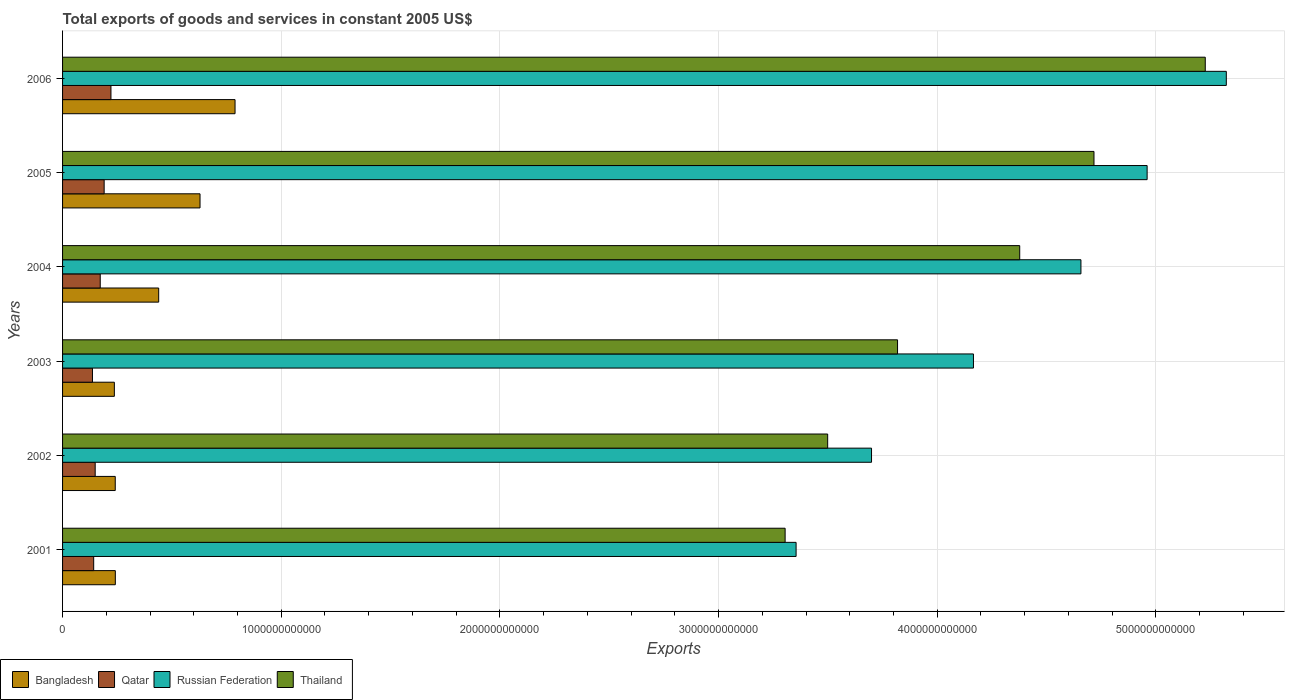Are the number of bars per tick equal to the number of legend labels?
Your answer should be very brief. Yes. How many bars are there on the 2nd tick from the bottom?
Offer a terse response. 4. In how many cases, is the number of bars for a given year not equal to the number of legend labels?
Your answer should be compact. 0. What is the total exports of goods and services in Thailand in 2004?
Your answer should be very brief. 4.38e+12. Across all years, what is the maximum total exports of goods and services in Russian Federation?
Provide a short and direct response. 5.32e+12. Across all years, what is the minimum total exports of goods and services in Bangladesh?
Keep it short and to the point. 2.37e+11. In which year was the total exports of goods and services in Russian Federation maximum?
Provide a short and direct response. 2006. In which year was the total exports of goods and services in Qatar minimum?
Your response must be concise. 2003. What is the total total exports of goods and services in Qatar in the graph?
Provide a short and direct response. 1.01e+12. What is the difference between the total exports of goods and services in Russian Federation in 2003 and that in 2004?
Provide a succinct answer. -4.92e+11. What is the difference between the total exports of goods and services in Bangladesh in 2004 and the total exports of goods and services in Thailand in 2005?
Give a very brief answer. -4.28e+12. What is the average total exports of goods and services in Russian Federation per year?
Offer a very short reply. 4.36e+12. In the year 2006, what is the difference between the total exports of goods and services in Qatar and total exports of goods and services in Russian Federation?
Provide a succinct answer. -5.10e+12. What is the ratio of the total exports of goods and services in Thailand in 2002 to that in 2006?
Your answer should be very brief. 0.67. Is the difference between the total exports of goods and services in Qatar in 2003 and 2005 greater than the difference between the total exports of goods and services in Russian Federation in 2003 and 2005?
Provide a succinct answer. Yes. What is the difference between the highest and the second highest total exports of goods and services in Bangladesh?
Offer a terse response. 1.60e+11. What is the difference between the highest and the lowest total exports of goods and services in Bangladesh?
Offer a very short reply. 5.52e+11. In how many years, is the total exports of goods and services in Russian Federation greater than the average total exports of goods and services in Russian Federation taken over all years?
Keep it short and to the point. 3. Is the sum of the total exports of goods and services in Qatar in 2001 and 2005 greater than the maximum total exports of goods and services in Bangladesh across all years?
Your response must be concise. No. What does the 4th bar from the top in 2005 represents?
Offer a very short reply. Bangladesh. What does the 2nd bar from the bottom in 2006 represents?
Your answer should be very brief. Qatar. Is it the case that in every year, the sum of the total exports of goods and services in Russian Federation and total exports of goods and services in Thailand is greater than the total exports of goods and services in Qatar?
Provide a short and direct response. Yes. How many bars are there?
Offer a terse response. 24. How many years are there in the graph?
Provide a short and direct response. 6. What is the difference between two consecutive major ticks on the X-axis?
Your response must be concise. 1.00e+12. Does the graph contain grids?
Give a very brief answer. Yes. Where does the legend appear in the graph?
Make the answer very short. Bottom left. How are the legend labels stacked?
Provide a short and direct response. Horizontal. What is the title of the graph?
Provide a short and direct response. Total exports of goods and services in constant 2005 US$. Does "Nepal" appear as one of the legend labels in the graph?
Your answer should be compact. No. What is the label or title of the X-axis?
Offer a terse response. Exports. What is the Exports in Bangladesh in 2001?
Make the answer very short. 2.41e+11. What is the Exports of Qatar in 2001?
Offer a terse response. 1.42e+11. What is the Exports of Russian Federation in 2001?
Your answer should be very brief. 3.35e+12. What is the Exports of Thailand in 2001?
Your response must be concise. 3.30e+12. What is the Exports of Bangladesh in 2002?
Your answer should be compact. 2.41e+11. What is the Exports in Qatar in 2002?
Your response must be concise. 1.49e+11. What is the Exports in Russian Federation in 2002?
Ensure brevity in your answer.  3.70e+12. What is the Exports of Thailand in 2002?
Offer a terse response. 3.50e+12. What is the Exports of Bangladesh in 2003?
Give a very brief answer. 2.37e+11. What is the Exports in Qatar in 2003?
Ensure brevity in your answer.  1.37e+11. What is the Exports of Russian Federation in 2003?
Provide a short and direct response. 4.17e+12. What is the Exports in Thailand in 2003?
Give a very brief answer. 3.82e+12. What is the Exports in Bangladesh in 2004?
Provide a short and direct response. 4.40e+11. What is the Exports of Qatar in 2004?
Your answer should be compact. 1.72e+11. What is the Exports in Russian Federation in 2004?
Ensure brevity in your answer.  4.66e+12. What is the Exports of Thailand in 2004?
Offer a very short reply. 4.38e+12. What is the Exports in Bangladesh in 2005?
Give a very brief answer. 6.29e+11. What is the Exports in Qatar in 2005?
Offer a very short reply. 1.90e+11. What is the Exports in Russian Federation in 2005?
Your answer should be very brief. 4.96e+12. What is the Exports of Thailand in 2005?
Give a very brief answer. 4.72e+12. What is the Exports of Bangladesh in 2006?
Make the answer very short. 7.89e+11. What is the Exports of Qatar in 2006?
Make the answer very short. 2.21e+11. What is the Exports in Russian Federation in 2006?
Offer a terse response. 5.32e+12. What is the Exports of Thailand in 2006?
Provide a succinct answer. 5.23e+12. Across all years, what is the maximum Exports of Bangladesh?
Ensure brevity in your answer.  7.89e+11. Across all years, what is the maximum Exports of Qatar?
Make the answer very short. 2.21e+11. Across all years, what is the maximum Exports in Russian Federation?
Ensure brevity in your answer.  5.32e+12. Across all years, what is the maximum Exports of Thailand?
Provide a short and direct response. 5.23e+12. Across all years, what is the minimum Exports in Bangladesh?
Your answer should be very brief. 2.37e+11. Across all years, what is the minimum Exports in Qatar?
Offer a terse response. 1.37e+11. Across all years, what is the minimum Exports of Russian Federation?
Your answer should be compact. 3.35e+12. Across all years, what is the minimum Exports of Thailand?
Your answer should be compact. 3.30e+12. What is the total Exports of Bangladesh in the graph?
Make the answer very short. 2.58e+12. What is the total Exports in Qatar in the graph?
Provide a succinct answer. 1.01e+12. What is the total Exports in Russian Federation in the graph?
Your answer should be very brief. 2.62e+13. What is the total Exports in Thailand in the graph?
Your answer should be compact. 2.49e+13. What is the difference between the Exports in Bangladesh in 2001 and that in 2002?
Your response must be concise. 3.96e+08. What is the difference between the Exports of Qatar in 2001 and that in 2002?
Ensure brevity in your answer.  -6.82e+09. What is the difference between the Exports of Russian Federation in 2001 and that in 2002?
Offer a very short reply. -3.45e+11. What is the difference between the Exports of Thailand in 2001 and that in 2002?
Your response must be concise. -1.95e+11. What is the difference between the Exports in Bangladesh in 2001 and that in 2003?
Make the answer very short. 4.48e+09. What is the difference between the Exports of Qatar in 2001 and that in 2003?
Ensure brevity in your answer.  5.58e+09. What is the difference between the Exports of Russian Federation in 2001 and that in 2003?
Offer a terse response. -8.11e+11. What is the difference between the Exports in Thailand in 2001 and that in 2003?
Offer a terse response. -5.14e+11. What is the difference between the Exports in Bangladesh in 2001 and that in 2004?
Provide a short and direct response. -1.98e+11. What is the difference between the Exports of Qatar in 2001 and that in 2004?
Keep it short and to the point. -3.00e+1. What is the difference between the Exports of Russian Federation in 2001 and that in 2004?
Provide a short and direct response. -1.30e+12. What is the difference between the Exports in Thailand in 2001 and that in 2004?
Offer a very short reply. -1.07e+12. What is the difference between the Exports in Bangladesh in 2001 and that in 2005?
Keep it short and to the point. -3.87e+11. What is the difference between the Exports in Qatar in 2001 and that in 2005?
Offer a very short reply. -4.78e+1. What is the difference between the Exports of Russian Federation in 2001 and that in 2005?
Your response must be concise. -1.61e+12. What is the difference between the Exports in Thailand in 2001 and that in 2005?
Offer a terse response. -1.41e+12. What is the difference between the Exports in Bangladesh in 2001 and that in 2006?
Your response must be concise. -5.47e+11. What is the difference between the Exports in Qatar in 2001 and that in 2006?
Your answer should be compact. -7.90e+1. What is the difference between the Exports of Russian Federation in 2001 and that in 2006?
Make the answer very short. -1.97e+12. What is the difference between the Exports in Thailand in 2001 and that in 2006?
Keep it short and to the point. -1.92e+12. What is the difference between the Exports of Bangladesh in 2002 and that in 2003?
Give a very brief answer. 4.09e+09. What is the difference between the Exports of Qatar in 2002 and that in 2003?
Provide a succinct answer. 1.24e+1. What is the difference between the Exports of Russian Federation in 2002 and that in 2003?
Your answer should be compact. -4.66e+11. What is the difference between the Exports of Thailand in 2002 and that in 2003?
Provide a short and direct response. -3.20e+11. What is the difference between the Exports of Bangladesh in 2002 and that in 2004?
Offer a very short reply. -1.99e+11. What is the difference between the Exports of Qatar in 2002 and that in 2004?
Give a very brief answer. -2.31e+1. What is the difference between the Exports of Russian Federation in 2002 and that in 2004?
Your answer should be compact. -9.58e+11. What is the difference between the Exports in Thailand in 2002 and that in 2004?
Provide a short and direct response. -8.78e+11. What is the difference between the Exports of Bangladesh in 2002 and that in 2005?
Provide a short and direct response. -3.88e+11. What is the difference between the Exports of Qatar in 2002 and that in 2005?
Your answer should be compact. -4.10e+1. What is the difference between the Exports of Russian Federation in 2002 and that in 2005?
Provide a succinct answer. -1.26e+12. What is the difference between the Exports of Thailand in 2002 and that in 2005?
Your answer should be compact. -1.22e+12. What is the difference between the Exports of Bangladesh in 2002 and that in 2006?
Keep it short and to the point. -5.48e+11. What is the difference between the Exports in Qatar in 2002 and that in 2006?
Your response must be concise. -7.21e+1. What is the difference between the Exports in Russian Federation in 2002 and that in 2006?
Your answer should be very brief. -1.62e+12. What is the difference between the Exports of Thailand in 2002 and that in 2006?
Your answer should be compact. -1.73e+12. What is the difference between the Exports in Bangladesh in 2003 and that in 2004?
Your response must be concise. -2.03e+11. What is the difference between the Exports in Qatar in 2003 and that in 2004?
Offer a terse response. -3.55e+1. What is the difference between the Exports in Russian Federation in 2003 and that in 2004?
Your answer should be compact. -4.92e+11. What is the difference between the Exports of Thailand in 2003 and that in 2004?
Provide a short and direct response. -5.59e+11. What is the difference between the Exports of Bangladesh in 2003 and that in 2005?
Your answer should be compact. -3.92e+11. What is the difference between the Exports in Qatar in 2003 and that in 2005?
Make the answer very short. -5.34e+1. What is the difference between the Exports in Russian Federation in 2003 and that in 2005?
Your answer should be very brief. -7.94e+11. What is the difference between the Exports of Thailand in 2003 and that in 2005?
Offer a very short reply. -8.98e+11. What is the difference between the Exports of Bangladesh in 2003 and that in 2006?
Your answer should be very brief. -5.52e+11. What is the difference between the Exports in Qatar in 2003 and that in 2006?
Provide a succinct answer. -8.45e+1. What is the difference between the Exports in Russian Federation in 2003 and that in 2006?
Keep it short and to the point. -1.16e+12. What is the difference between the Exports of Thailand in 2003 and that in 2006?
Make the answer very short. -1.41e+12. What is the difference between the Exports of Bangladesh in 2004 and that in 2005?
Make the answer very short. -1.89e+11. What is the difference between the Exports of Qatar in 2004 and that in 2005?
Give a very brief answer. -1.79e+1. What is the difference between the Exports in Russian Federation in 2004 and that in 2005?
Give a very brief answer. -3.03e+11. What is the difference between the Exports in Thailand in 2004 and that in 2005?
Offer a very short reply. -3.40e+11. What is the difference between the Exports of Bangladesh in 2004 and that in 2006?
Your answer should be compact. -3.49e+11. What is the difference between the Exports in Qatar in 2004 and that in 2006?
Offer a very short reply. -4.90e+1. What is the difference between the Exports in Russian Federation in 2004 and that in 2006?
Provide a short and direct response. -6.65e+11. What is the difference between the Exports of Thailand in 2004 and that in 2006?
Make the answer very short. -8.49e+11. What is the difference between the Exports of Bangladesh in 2005 and that in 2006?
Make the answer very short. -1.60e+11. What is the difference between the Exports of Qatar in 2005 and that in 2006?
Your answer should be very brief. -3.11e+1. What is the difference between the Exports of Russian Federation in 2005 and that in 2006?
Offer a terse response. -3.62e+11. What is the difference between the Exports in Thailand in 2005 and that in 2006?
Ensure brevity in your answer.  -5.09e+11. What is the difference between the Exports in Bangladesh in 2001 and the Exports in Qatar in 2002?
Your answer should be very brief. 9.22e+1. What is the difference between the Exports of Bangladesh in 2001 and the Exports of Russian Federation in 2002?
Your answer should be compact. -3.46e+12. What is the difference between the Exports of Bangladesh in 2001 and the Exports of Thailand in 2002?
Provide a short and direct response. -3.26e+12. What is the difference between the Exports of Qatar in 2001 and the Exports of Russian Federation in 2002?
Provide a short and direct response. -3.56e+12. What is the difference between the Exports in Qatar in 2001 and the Exports in Thailand in 2002?
Make the answer very short. -3.36e+12. What is the difference between the Exports of Russian Federation in 2001 and the Exports of Thailand in 2002?
Your response must be concise. -1.44e+11. What is the difference between the Exports of Bangladesh in 2001 and the Exports of Qatar in 2003?
Offer a terse response. 1.05e+11. What is the difference between the Exports in Bangladesh in 2001 and the Exports in Russian Federation in 2003?
Make the answer very short. -3.92e+12. What is the difference between the Exports in Bangladesh in 2001 and the Exports in Thailand in 2003?
Give a very brief answer. -3.58e+12. What is the difference between the Exports of Qatar in 2001 and the Exports of Russian Federation in 2003?
Give a very brief answer. -4.02e+12. What is the difference between the Exports in Qatar in 2001 and the Exports in Thailand in 2003?
Offer a very short reply. -3.68e+12. What is the difference between the Exports of Russian Federation in 2001 and the Exports of Thailand in 2003?
Ensure brevity in your answer.  -4.64e+11. What is the difference between the Exports in Bangladesh in 2001 and the Exports in Qatar in 2004?
Your answer should be compact. 6.90e+1. What is the difference between the Exports of Bangladesh in 2001 and the Exports of Russian Federation in 2004?
Give a very brief answer. -4.42e+12. What is the difference between the Exports of Bangladesh in 2001 and the Exports of Thailand in 2004?
Make the answer very short. -4.14e+12. What is the difference between the Exports in Qatar in 2001 and the Exports in Russian Federation in 2004?
Offer a terse response. -4.51e+12. What is the difference between the Exports in Qatar in 2001 and the Exports in Thailand in 2004?
Offer a terse response. -4.23e+12. What is the difference between the Exports in Russian Federation in 2001 and the Exports in Thailand in 2004?
Your answer should be compact. -1.02e+12. What is the difference between the Exports of Bangladesh in 2001 and the Exports of Qatar in 2005?
Ensure brevity in your answer.  5.12e+1. What is the difference between the Exports in Bangladesh in 2001 and the Exports in Russian Federation in 2005?
Give a very brief answer. -4.72e+12. What is the difference between the Exports of Bangladesh in 2001 and the Exports of Thailand in 2005?
Offer a very short reply. -4.48e+12. What is the difference between the Exports of Qatar in 2001 and the Exports of Russian Federation in 2005?
Provide a short and direct response. -4.82e+12. What is the difference between the Exports of Qatar in 2001 and the Exports of Thailand in 2005?
Offer a terse response. -4.57e+12. What is the difference between the Exports of Russian Federation in 2001 and the Exports of Thailand in 2005?
Make the answer very short. -1.36e+12. What is the difference between the Exports in Bangladesh in 2001 and the Exports in Qatar in 2006?
Offer a terse response. 2.00e+1. What is the difference between the Exports of Bangladesh in 2001 and the Exports of Russian Federation in 2006?
Ensure brevity in your answer.  -5.08e+12. What is the difference between the Exports in Bangladesh in 2001 and the Exports in Thailand in 2006?
Keep it short and to the point. -4.98e+12. What is the difference between the Exports in Qatar in 2001 and the Exports in Russian Federation in 2006?
Your answer should be compact. -5.18e+12. What is the difference between the Exports of Qatar in 2001 and the Exports of Thailand in 2006?
Your answer should be very brief. -5.08e+12. What is the difference between the Exports of Russian Federation in 2001 and the Exports of Thailand in 2006?
Make the answer very short. -1.87e+12. What is the difference between the Exports in Bangladesh in 2002 and the Exports in Qatar in 2003?
Make the answer very short. 1.04e+11. What is the difference between the Exports of Bangladesh in 2002 and the Exports of Russian Federation in 2003?
Give a very brief answer. -3.92e+12. What is the difference between the Exports of Bangladesh in 2002 and the Exports of Thailand in 2003?
Ensure brevity in your answer.  -3.58e+12. What is the difference between the Exports of Qatar in 2002 and the Exports of Russian Federation in 2003?
Keep it short and to the point. -4.02e+12. What is the difference between the Exports in Qatar in 2002 and the Exports in Thailand in 2003?
Make the answer very short. -3.67e+12. What is the difference between the Exports of Russian Federation in 2002 and the Exports of Thailand in 2003?
Make the answer very short. -1.19e+11. What is the difference between the Exports of Bangladesh in 2002 and the Exports of Qatar in 2004?
Offer a terse response. 6.86e+1. What is the difference between the Exports in Bangladesh in 2002 and the Exports in Russian Federation in 2004?
Your response must be concise. -4.42e+12. What is the difference between the Exports of Bangladesh in 2002 and the Exports of Thailand in 2004?
Provide a short and direct response. -4.14e+12. What is the difference between the Exports in Qatar in 2002 and the Exports in Russian Federation in 2004?
Your answer should be very brief. -4.51e+12. What is the difference between the Exports of Qatar in 2002 and the Exports of Thailand in 2004?
Give a very brief answer. -4.23e+12. What is the difference between the Exports of Russian Federation in 2002 and the Exports of Thailand in 2004?
Ensure brevity in your answer.  -6.78e+11. What is the difference between the Exports in Bangladesh in 2002 and the Exports in Qatar in 2005?
Offer a terse response. 5.08e+1. What is the difference between the Exports of Bangladesh in 2002 and the Exports of Russian Federation in 2005?
Your answer should be compact. -4.72e+12. What is the difference between the Exports in Bangladesh in 2002 and the Exports in Thailand in 2005?
Offer a very short reply. -4.48e+12. What is the difference between the Exports of Qatar in 2002 and the Exports of Russian Federation in 2005?
Give a very brief answer. -4.81e+12. What is the difference between the Exports in Qatar in 2002 and the Exports in Thailand in 2005?
Provide a short and direct response. -4.57e+12. What is the difference between the Exports of Russian Federation in 2002 and the Exports of Thailand in 2005?
Provide a short and direct response. -1.02e+12. What is the difference between the Exports of Bangladesh in 2002 and the Exports of Qatar in 2006?
Offer a terse response. 1.96e+1. What is the difference between the Exports of Bangladesh in 2002 and the Exports of Russian Federation in 2006?
Your answer should be compact. -5.08e+12. What is the difference between the Exports of Bangladesh in 2002 and the Exports of Thailand in 2006?
Ensure brevity in your answer.  -4.98e+12. What is the difference between the Exports of Qatar in 2002 and the Exports of Russian Federation in 2006?
Give a very brief answer. -5.17e+12. What is the difference between the Exports in Qatar in 2002 and the Exports in Thailand in 2006?
Offer a very short reply. -5.08e+12. What is the difference between the Exports in Russian Federation in 2002 and the Exports in Thailand in 2006?
Keep it short and to the point. -1.53e+12. What is the difference between the Exports in Bangladesh in 2003 and the Exports in Qatar in 2004?
Give a very brief answer. 6.45e+1. What is the difference between the Exports of Bangladesh in 2003 and the Exports of Russian Federation in 2004?
Your answer should be very brief. -4.42e+12. What is the difference between the Exports in Bangladesh in 2003 and the Exports in Thailand in 2004?
Keep it short and to the point. -4.14e+12. What is the difference between the Exports in Qatar in 2003 and the Exports in Russian Federation in 2004?
Offer a very short reply. -4.52e+12. What is the difference between the Exports in Qatar in 2003 and the Exports in Thailand in 2004?
Keep it short and to the point. -4.24e+12. What is the difference between the Exports in Russian Federation in 2003 and the Exports in Thailand in 2004?
Your response must be concise. -2.12e+11. What is the difference between the Exports in Bangladesh in 2003 and the Exports in Qatar in 2005?
Provide a succinct answer. 4.67e+1. What is the difference between the Exports in Bangladesh in 2003 and the Exports in Russian Federation in 2005?
Your response must be concise. -4.72e+12. What is the difference between the Exports of Bangladesh in 2003 and the Exports of Thailand in 2005?
Ensure brevity in your answer.  -4.48e+12. What is the difference between the Exports of Qatar in 2003 and the Exports of Russian Federation in 2005?
Make the answer very short. -4.82e+12. What is the difference between the Exports of Qatar in 2003 and the Exports of Thailand in 2005?
Offer a terse response. -4.58e+12. What is the difference between the Exports of Russian Federation in 2003 and the Exports of Thailand in 2005?
Keep it short and to the point. -5.51e+11. What is the difference between the Exports of Bangladesh in 2003 and the Exports of Qatar in 2006?
Give a very brief answer. 1.55e+1. What is the difference between the Exports of Bangladesh in 2003 and the Exports of Russian Federation in 2006?
Offer a terse response. -5.09e+12. What is the difference between the Exports in Bangladesh in 2003 and the Exports in Thailand in 2006?
Keep it short and to the point. -4.99e+12. What is the difference between the Exports in Qatar in 2003 and the Exports in Russian Federation in 2006?
Your answer should be very brief. -5.19e+12. What is the difference between the Exports of Qatar in 2003 and the Exports of Thailand in 2006?
Your response must be concise. -5.09e+12. What is the difference between the Exports of Russian Federation in 2003 and the Exports of Thailand in 2006?
Provide a short and direct response. -1.06e+12. What is the difference between the Exports of Bangladesh in 2004 and the Exports of Qatar in 2005?
Keep it short and to the point. 2.49e+11. What is the difference between the Exports of Bangladesh in 2004 and the Exports of Russian Federation in 2005?
Provide a short and direct response. -4.52e+12. What is the difference between the Exports in Bangladesh in 2004 and the Exports in Thailand in 2005?
Provide a succinct answer. -4.28e+12. What is the difference between the Exports of Qatar in 2004 and the Exports of Russian Federation in 2005?
Ensure brevity in your answer.  -4.79e+12. What is the difference between the Exports of Qatar in 2004 and the Exports of Thailand in 2005?
Keep it short and to the point. -4.54e+12. What is the difference between the Exports in Russian Federation in 2004 and the Exports in Thailand in 2005?
Offer a very short reply. -5.97e+1. What is the difference between the Exports in Bangladesh in 2004 and the Exports in Qatar in 2006?
Provide a succinct answer. 2.18e+11. What is the difference between the Exports in Bangladesh in 2004 and the Exports in Russian Federation in 2006?
Keep it short and to the point. -4.88e+12. What is the difference between the Exports of Bangladesh in 2004 and the Exports of Thailand in 2006?
Offer a terse response. -4.79e+12. What is the difference between the Exports in Qatar in 2004 and the Exports in Russian Federation in 2006?
Make the answer very short. -5.15e+12. What is the difference between the Exports of Qatar in 2004 and the Exports of Thailand in 2006?
Your answer should be compact. -5.05e+12. What is the difference between the Exports of Russian Federation in 2004 and the Exports of Thailand in 2006?
Your response must be concise. -5.69e+11. What is the difference between the Exports of Bangladesh in 2005 and the Exports of Qatar in 2006?
Make the answer very short. 4.07e+11. What is the difference between the Exports of Bangladesh in 2005 and the Exports of Russian Federation in 2006?
Give a very brief answer. -4.69e+12. What is the difference between the Exports of Bangladesh in 2005 and the Exports of Thailand in 2006?
Offer a terse response. -4.60e+12. What is the difference between the Exports of Qatar in 2005 and the Exports of Russian Federation in 2006?
Provide a succinct answer. -5.13e+12. What is the difference between the Exports of Qatar in 2005 and the Exports of Thailand in 2006?
Provide a short and direct response. -5.04e+12. What is the difference between the Exports in Russian Federation in 2005 and the Exports in Thailand in 2006?
Give a very brief answer. -2.66e+11. What is the average Exports in Bangladesh per year?
Ensure brevity in your answer.  4.29e+11. What is the average Exports of Qatar per year?
Provide a succinct answer. 1.69e+11. What is the average Exports of Russian Federation per year?
Your answer should be very brief. 4.36e+12. What is the average Exports in Thailand per year?
Ensure brevity in your answer.  4.16e+12. In the year 2001, what is the difference between the Exports of Bangladesh and Exports of Qatar?
Provide a short and direct response. 9.90e+1. In the year 2001, what is the difference between the Exports of Bangladesh and Exports of Russian Federation?
Make the answer very short. -3.11e+12. In the year 2001, what is the difference between the Exports of Bangladesh and Exports of Thailand?
Offer a terse response. -3.06e+12. In the year 2001, what is the difference between the Exports in Qatar and Exports in Russian Federation?
Offer a terse response. -3.21e+12. In the year 2001, what is the difference between the Exports of Qatar and Exports of Thailand?
Give a very brief answer. -3.16e+12. In the year 2001, what is the difference between the Exports of Russian Federation and Exports of Thailand?
Provide a short and direct response. 5.01e+1. In the year 2002, what is the difference between the Exports in Bangladesh and Exports in Qatar?
Keep it short and to the point. 9.18e+1. In the year 2002, what is the difference between the Exports in Bangladesh and Exports in Russian Federation?
Provide a short and direct response. -3.46e+12. In the year 2002, what is the difference between the Exports of Bangladesh and Exports of Thailand?
Give a very brief answer. -3.26e+12. In the year 2002, what is the difference between the Exports of Qatar and Exports of Russian Federation?
Your answer should be compact. -3.55e+12. In the year 2002, what is the difference between the Exports of Qatar and Exports of Thailand?
Your answer should be compact. -3.35e+12. In the year 2002, what is the difference between the Exports of Russian Federation and Exports of Thailand?
Provide a short and direct response. 2.01e+11. In the year 2003, what is the difference between the Exports of Bangladesh and Exports of Qatar?
Your answer should be compact. 1.00e+11. In the year 2003, what is the difference between the Exports in Bangladesh and Exports in Russian Federation?
Offer a very short reply. -3.93e+12. In the year 2003, what is the difference between the Exports of Bangladesh and Exports of Thailand?
Give a very brief answer. -3.58e+12. In the year 2003, what is the difference between the Exports in Qatar and Exports in Russian Federation?
Your answer should be very brief. -4.03e+12. In the year 2003, what is the difference between the Exports of Qatar and Exports of Thailand?
Keep it short and to the point. -3.68e+12. In the year 2003, what is the difference between the Exports in Russian Federation and Exports in Thailand?
Provide a succinct answer. 3.47e+11. In the year 2004, what is the difference between the Exports in Bangladesh and Exports in Qatar?
Provide a short and direct response. 2.67e+11. In the year 2004, what is the difference between the Exports of Bangladesh and Exports of Russian Federation?
Give a very brief answer. -4.22e+12. In the year 2004, what is the difference between the Exports of Bangladesh and Exports of Thailand?
Provide a succinct answer. -3.94e+12. In the year 2004, what is the difference between the Exports of Qatar and Exports of Russian Federation?
Your response must be concise. -4.48e+12. In the year 2004, what is the difference between the Exports in Qatar and Exports in Thailand?
Offer a very short reply. -4.21e+12. In the year 2004, what is the difference between the Exports of Russian Federation and Exports of Thailand?
Your answer should be very brief. 2.80e+11. In the year 2005, what is the difference between the Exports of Bangladesh and Exports of Qatar?
Ensure brevity in your answer.  4.38e+11. In the year 2005, what is the difference between the Exports in Bangladesh and Exports in Russian Federation?
Keep it short and to the point. -4.33e+12. In the year 2005, what is the difference between the Exports in Bangladesh and Exports in Thailand?
Ensure brevity in your answer.  -4.09e+12. In the year 2005, what is the difference between the Exports of Qatar and Exports of Russian Federation?
Your response must be concise. -4.77e+12. In the year 2005, what is the difference between the Exports of Qatar and Exports of Thailand?
Keep it short and to the point. -4.53e+12. In the year 2005, what is the difference between the Exports of Russian Federation and Exports of Thailand?
Make the answer very short. 2.43e+11. In the year 2006, what is the difference between the Exports in Bangladesh and Exports in Qatar?
Provide a succinct answer. 5.67e+11. In the year 2006, what is the difference between the Exports of Bangladesh and Exports of Russian Federation?
Make the answer very short. -4.53e+12. In the year 2006, what is the difference between the Exports of Bangladesh and Exports of Thailand?
Your answer should be compact. -4.44e+12. In the year 2006, what is the difference between the Exports in Qatar and Exports in Russian Federation?
Your answer should be very brief. -5.10e+12. In the year 2006, what is the difference between the Exports in Qatar and Exports in Thailand?
Ensure brevity in your answer.  -5.00e+12. In the year 2006, what is the difference between the Exports of Russian Federation and Exports of Thailand?
Provide a succinct answer. 9.62e+1. What is the ratio of the Exports of Qatar in 2001 to that in 2002?
Offer a very short reply. 0.95. What is the ratio of the Exports of Russian Federation in 2001 to that in 2002?
Provide a short and direct response. 0.91. What is the ratio of the Exports in Thailand in 2001 to that in 2002?
Provide a succinct answer. 0.94. What is the ratio of the Exports of Bangladesh in 2001 to that in 2003?
Make the answer very short. 1.02. What is the ratio of the Exports of Qatar in 2001 to that in 2003?
Your answer should be very brief. 1.04. What is the ratio of the Exports in Russian Federation in 2001 to that in 2003?
Provide a short and direct response. 0.81. What is the ratio of the Exports of Thailand in 2001 to that in 2003?
Provide a short and direct response. 0.87. What is the ratio of the Exports in Bangladesh in 2001 to that in 2004?
Offer a very short reply. 0.55. What is the ratio of the Exports of Qatar in 2001 to that in 2004?
Your response must be concise. 0.83. What is the ratio of the Exports in Russian Federation in 2001 to that in 2004?
Give a very brief answer. 0.72. What is the ratio of the Exports of Thailand in 2001 to that in 2004?
Your answer should be very brief. 0.75. What is the ratio of the Exports in Bangladesh in 2001 to that in 2005?
Your answer should be very brief. 0.38. What is the ratio of the Exports of Qatar in 2001 to that in 2005?
Ensure brevity in your answer.  0.75. What is the ratio of the Exports in Russian Federation in 2001 to that in 2005?
Offer a very short reply. 0.68. What is the ratio of the Exports in Thailand in 2001 to that in 2005?
Give a very brief answer. 0.7. What is the ratio of the Exports in Bangladesh in 2001 to that in 2006?
Offer a terse response. 0.31. What is the ratio of the Exports in Qatar in 2001 to that in 2006?
Make the answer very short. 0.64. What is the ratio of the Exports in Russian Federation in 2001 to that in 2006?
Ensure brevity in your answer.  0.63. What is the ratio of the Exports in Thailand in 2001 to that in 2006?
Ensure brevity in your answer.  0.63. What is the ratio of the Exports of Bangladesh in 2002 to that in 2003?
Make the answer very short. 1.02. What is the ratio of the Exports of Qatar in 2002 to that in 2003?
Keep it short and to the point. 1.09. What is the ratio of the Exports of Russian Federation in 2002 to that in 2003?
Your answer should be compact. 0.89. What is the ratio of the Exports in Thailand in 2002 to that in 2003?
Provide a short and direct response. 0.92. What is the ratio of the Exports in Bangladesh in 2002 to that in 2004?
Ensure brevity in your answer.  0.55. What is the ratio of the Exports in Qatar in 2002 to that in 2004?
Your answer should be compact. 0.87. What is the ratio of the Exports of Russian Federation in 2002 to that in 2004?
Provide a short and direct response. 0.79. What is the ratio of the Exports in Thailand in 2002 to that in 2004?
Ensure brevity in your answer.  0.8. What is the ratio of the Exports in Bangladesh in 2002 to that in 2005?
Provide a succinct answer. 0.38. What is the ratio of the Exports of Qatar in 2002 to that in 2005?
Provide a short and direct response. 0.78. What is the ratio of the Exports in Russian Federation in 2002 to that in 2005?
Offer a terse response. 0.75. What is the ratio of the Exports of Thailand in 2002 to that in 2005?
Make the answer very short. 0.74. What is the ratio of the Exports in Bangladesh in 2002 to that in 2006?
Ensure brevity in your answer.  0.31. What is the ratio of the Exports in Qatar in 2002 to that in 2006?
Make the answer very short. 0.67. What is the ratio of the Exports in Russian Federation in 2002 to that in 2006?
Offer a terse response. 0.7. What is the ratio of the Exports in Thailand in 2002 to that in 2006?
Your response must be concise. 0.67. What is the ratio of the Exports in Bangladesh in 2003 to that in 2004?
Give a very brief answer. 0.54. What is the ratio of the Exports of Qatar in 2003 to that in 2004?
Give a very brief answer. 0.79. What is the ratio of the Exports in Russian Federation in 2003 to that in 2004?
Provide a short and direct response. 0.89. What is the ratio of the Exports of Thailand in 2003 to that in 2004?
Provide a succinct answer. 0.87. What is the ratio of the Exports of Bangladesh in 2003 to that in 2005?
Give a very brief answer. 0.38. What is the ratio of the Exports of Qatar in 2003 to that in 2005?
Your answer should be very brief. 0.72. What is the ratio of the Exports of Russian Federation in 2003 to that in 2005?
Make the answer very short. 0.84. What is the ratio of the Exports of Thailand in 2003 to that in 2005?
Your answer should be compact. 0.81. What is the ratio of the Exports in Bangladesh in 2003 to that in 2006?
Make the answer very short. 0.3. What is the ratio of the Exports of Qatar in 2003 to that in 2006?
Offer a terse response. 0.62. What is the ratio of the Exports in Russian Federation in 2003 to that in 2006?
Give a very brief answer. 0.78. What is the ratio of the Exports in Thailand in 2003 to that in 2006?
Your response must be concise. 0.73. What is the ratio of the Exports of Bangladesh in 2004 to that in 2005?
Your answer should be very brief. 0.7. What is the ratio of the Exports of Qatar in 2004 to that in 2005?
Give a very brief answer. 0.91. What is the ratio of the Exports in Russian Federation in 2004 to that in 2005?
Your answer should be very brief. 0.94. What is the ratio of the Exports of Thailand in 2004 to that in 2005?
Your response must be concise. 0.93. What is the ratio of the Exports in Bangladesh in 2004 to that in 2006?
Ensure brevity in your answer.  0.56. What is the ratio of the Exports in Qatar in 2004 to that in 2006?
Offer a very short reply. 0.78. What is the ratio of the Exports of Russian Federation in 2004 to that in 2006?
Offer a terse response. 0.88. What is the ratio of the Exports in Thailand in 2004 to that in 2006?
Provide a short and direct response. 0.84. What is the ratio of the Exports in Bangladesh in 2005 to that in 2006?
Give a very brief answer. 0.8. What is the ratio of the Exports of Qatar in 2005 to that in 2006?
Provide a succinct answer. 0.86. What is the ratio of the Exports of Russian Federation in 2005 to that in 2006?
Provide a succinct answer. 0.93. What is the ratio of the Exports of Thailand in 2005 to that in 2006?
Provide a short and direct response. 0.9. What is the difference between the highest and the second highest Exports of Bangladesh?
Ensure brevity in your answer.  1.60e+11. What is the difference between the highest and the second highest Exports in Qatar?
Ensure brevity in your answer.  3.11e+1. What is the difference between the highest and the second highest Exports of Russian Federation?
Keep it short and to the point. 3.62e+11. What is the difference between the highest and the second highest Exports in Thailand?
Provide a short and direct response. 5.09e+11. What is the difference between the highest and the lowest Exports in Bangladesh?
Offer a very short reply. 5.52e+11. What is the difference between the highest and the lowest Exports of Qatar?
Keep it short and to the point. 8.45e+1. What is the difference between the highest and the lowest Exports in Russian Federation?
Ensure brevity in your answer.  1.97e+12. What is the difference between the highest and the lowest Exports of Thailand?
Ensure brevity in your answer.  1.92e+12. 